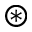<formula> <loc_0><loc_0><loc_500><loc_500>\circledast</formula> 